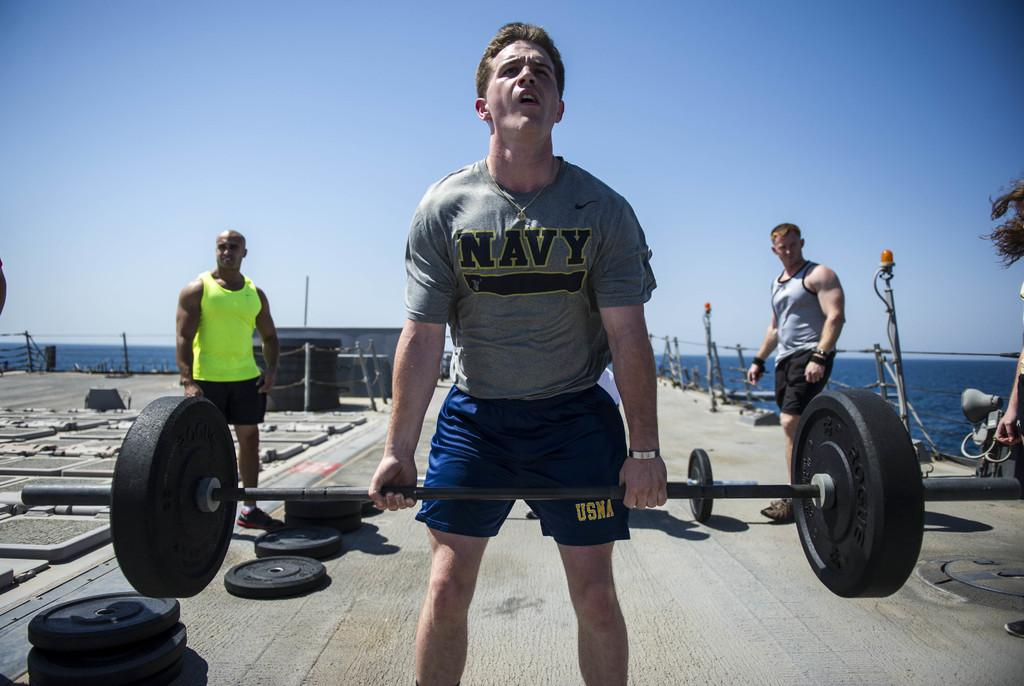<image>
Render a clear and concise summary of the photo. A man is lifting weights on the deck of a military ship and his shirt says Navy. 